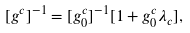<formula> <loc_0><loc_0><loc_500><loc_500>[ g ^ { c } ] ^ { - 1 } = [ g ^ { c } _ { 0 } ] ^ { - 1 } [ 1 + g ^ { c } _ { 0 } \lambda _ { c } ] ,</formula> 